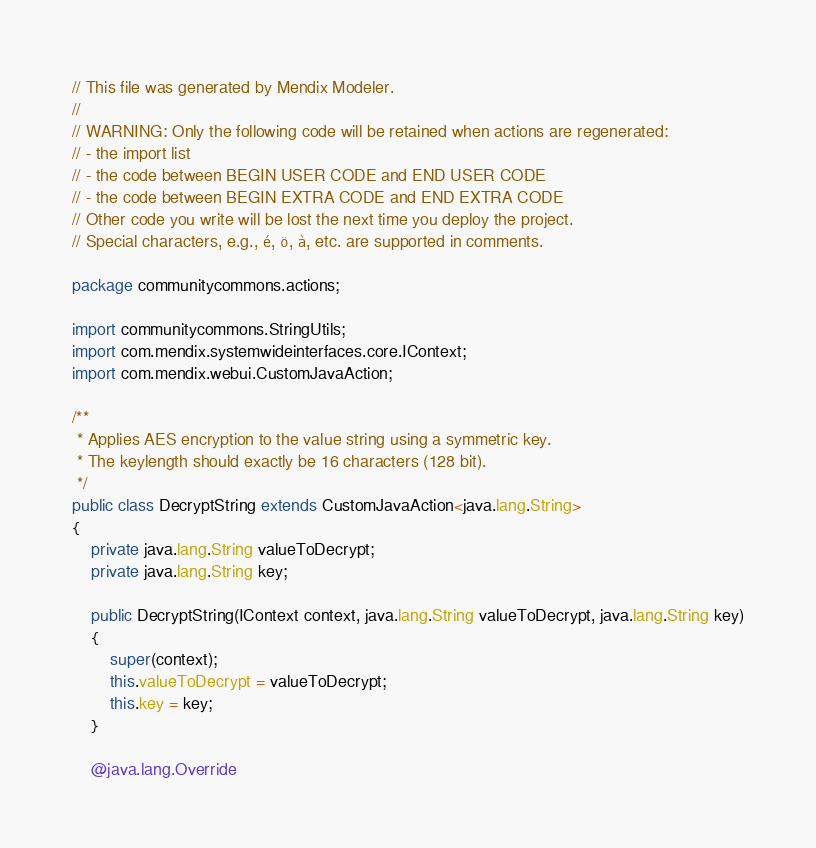Convert code to text. <code><loc_0><loc_0><loc_500><loc_500><_Java_>// This file was generated by Mendix Modeler.
//
// WARNING: Only the following code will be retained when actions are regenerated:
// - the import list
// - the code between BEGIN USER CODE and END USER CODE
// - the code between BEGIN EXTRA CODE and END EXTRA CODE
// Other code you write will be lost the next time you deploy the project.
// Special characters, e.g., é, ö, à, etc. are supported in comments.

package communitycommons.actions;

import communitycommons.StringUtils;
import com.mendix.systemwideinterfaces.core.IContext;
import com.mendix.webui.CustomJavaAction;

/**
 * Applies AES encryption to the value string using a symmetric key. 
 * The keylength should exactly be 16 characters (128 bit).
 */
public class DecryptString extends CustomJavaAction<java.lang.String>
{
	private java.lang.String valueToDecrypt;
	private java.lang.String key;

	public DecryptString(IContext context, java.lang.String valueToDecrypt, java.lang.String key)
	{
		super(context);
		this.valueToDecrypt = valueToDecrypt;
		this.key = key;
	}

	@java.lang.Override</code> 